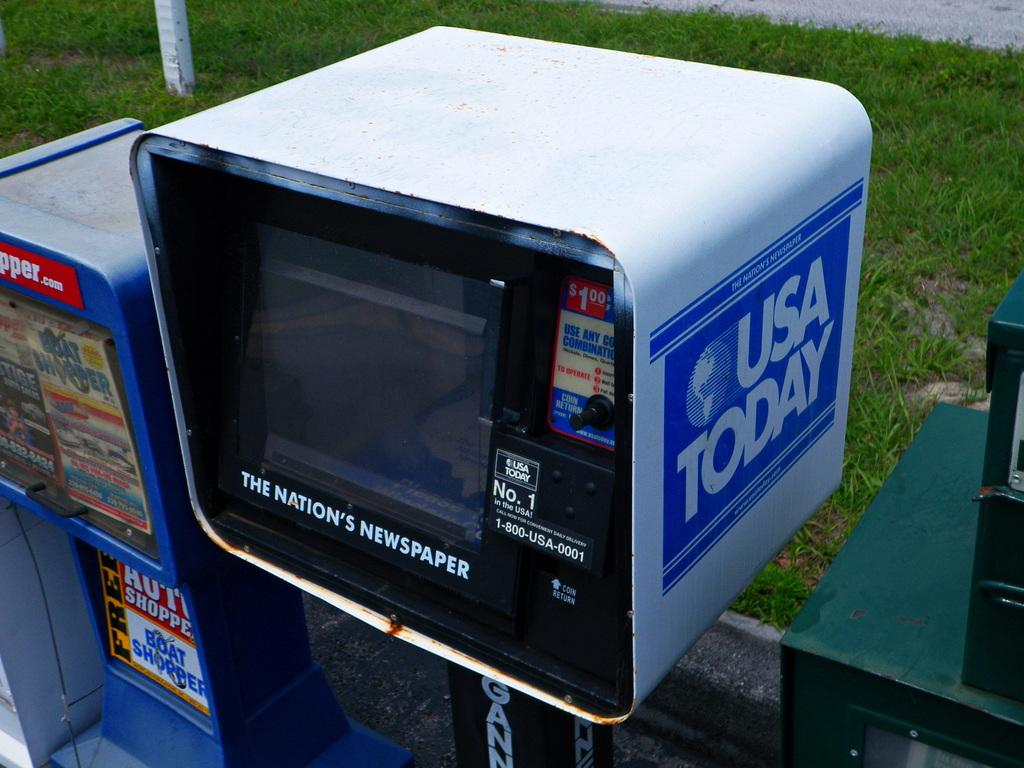<image>
Present a compact description of the photo's key features. A box for USA Today has the phrase "The Nation's Newspaper" printed on it. 